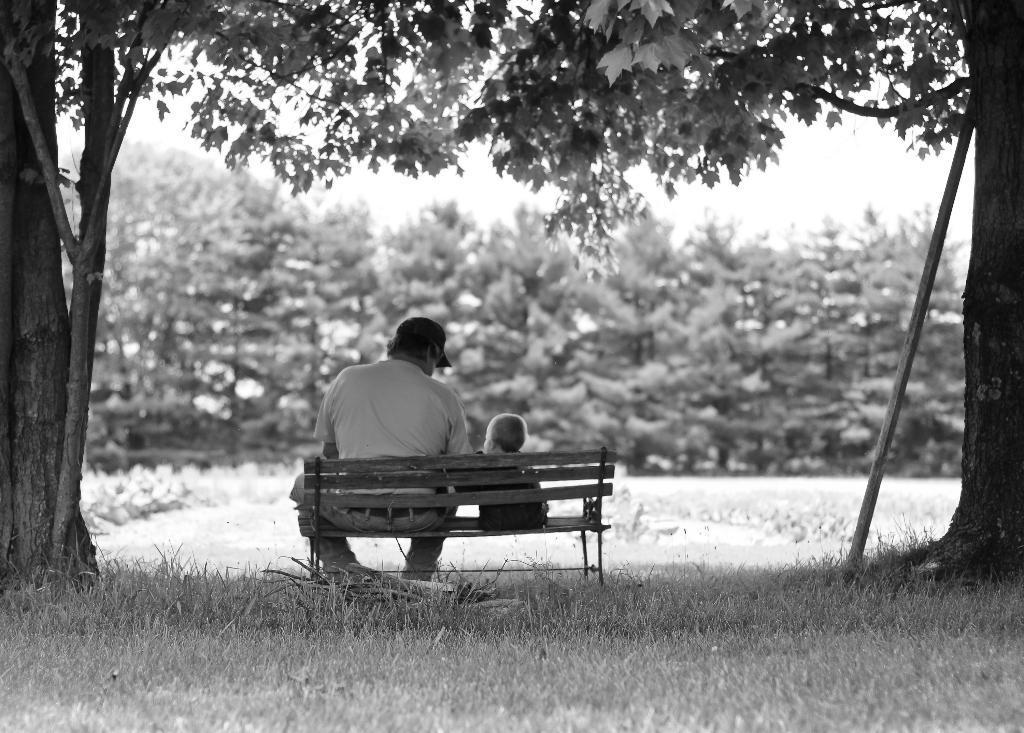How would you summarize this image in a sentence or two? in a picture there is a garden in which there is a bench on the bench there is a person and a boy sitting near to the bench there are many trees there is a grass on the floor. 